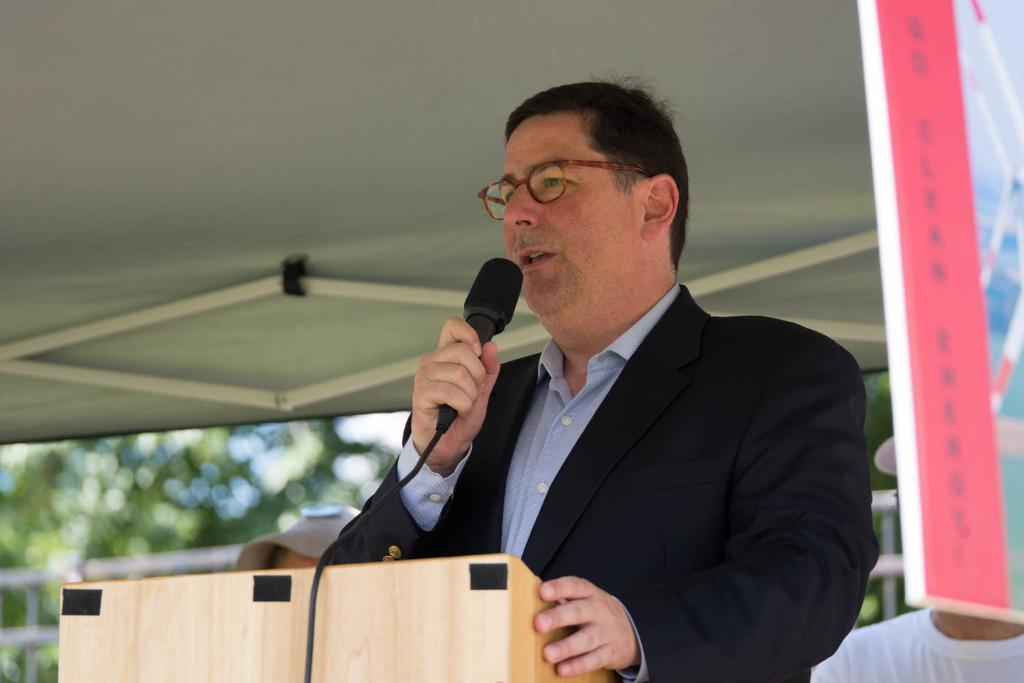What is the person in the image wearing? The person in the image is wearing a black suit. What is the person doing in the image? The person is standing and speaking in front of a microphone. What is in front of the person while they are speaking? There is a wooden stand in front of the person. Are there any other people present in the image? Yes, there are two other persons standing behind the person. What type of bell can be heard ringing in the image? There is no bell present in the image, and therefore no sound can be heard. 